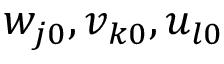Convert formula to latex. <formula><loc_0><loc_0><loc_500><loc_500>w _ { j 0 } , v _ { k 0 } , u _ { l 0 }</formula> 